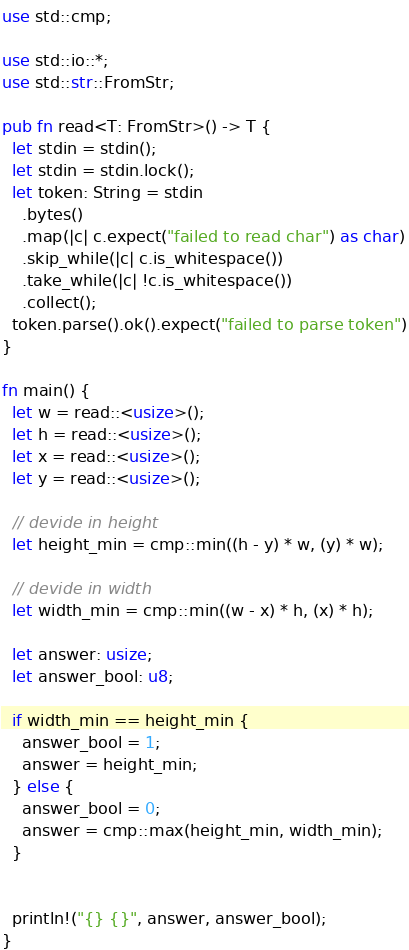Convert code to text. <code><loc_0><loc_0><loc_500><loc_500><_Rust_>use std::cmp;

use std::io::*;
use std::str::FromStr;

pub fn read<T: FromStr>() -> T {
  let stdin = stdin();
  let stdin = stdin.lock();
  let token: String = stdin
    .bytes()
    .map(|c| c.expect("failed to read char") as char)
    .skip_while(|c| c.is_whitespace())
    .take_while(|c| !c.is_whitespace())
    .collect();
  token.parse().ok().expect("failed to parse token")
}

fn main() {
  let w = read::<usize>();
  let h = read::<usize>();
  let x = read::<usize>();
  let y = read::<usize>();

  // devide in height
  let height_min = cmp::min((h - y) * w, (y) * w);

  // devide in width
  let width_min = cmp::min((w - x) * h, (x) * h);

  let answer: usize;
  let answer_bool: u8;

  if width_min == height_min {
    answer_bool = 1;
    answer = height_min;
  } else {
    answer_bool = 0;
    answer = cmp::max(height_min, width_min);
  }


  println!("{} {}", answer, answer_bool);
}</code> 